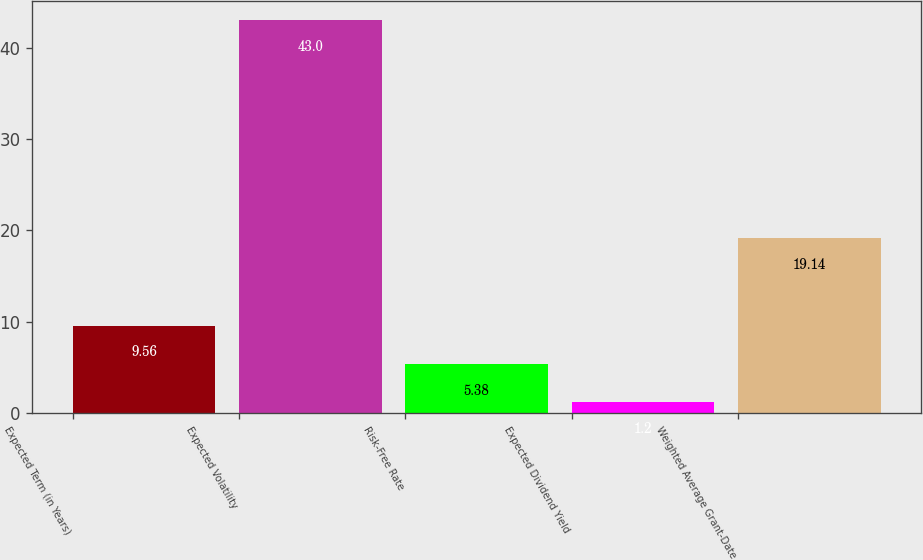Convert chart to OTSL. <chart><loc_0><loc_0><loc_500><loc_500><bar_chart><fcel>Expected Term (in Years)<fcel>Expected Volatility<fcel>Risk-Free Rate<fcel>Expected Dividend Yield<fcel>Weighted Average Grant-Date<nl><fcel>9.56<fcel>43<fcel>5.38<fcel>1.2<fcel>19.14<nl></chart> 